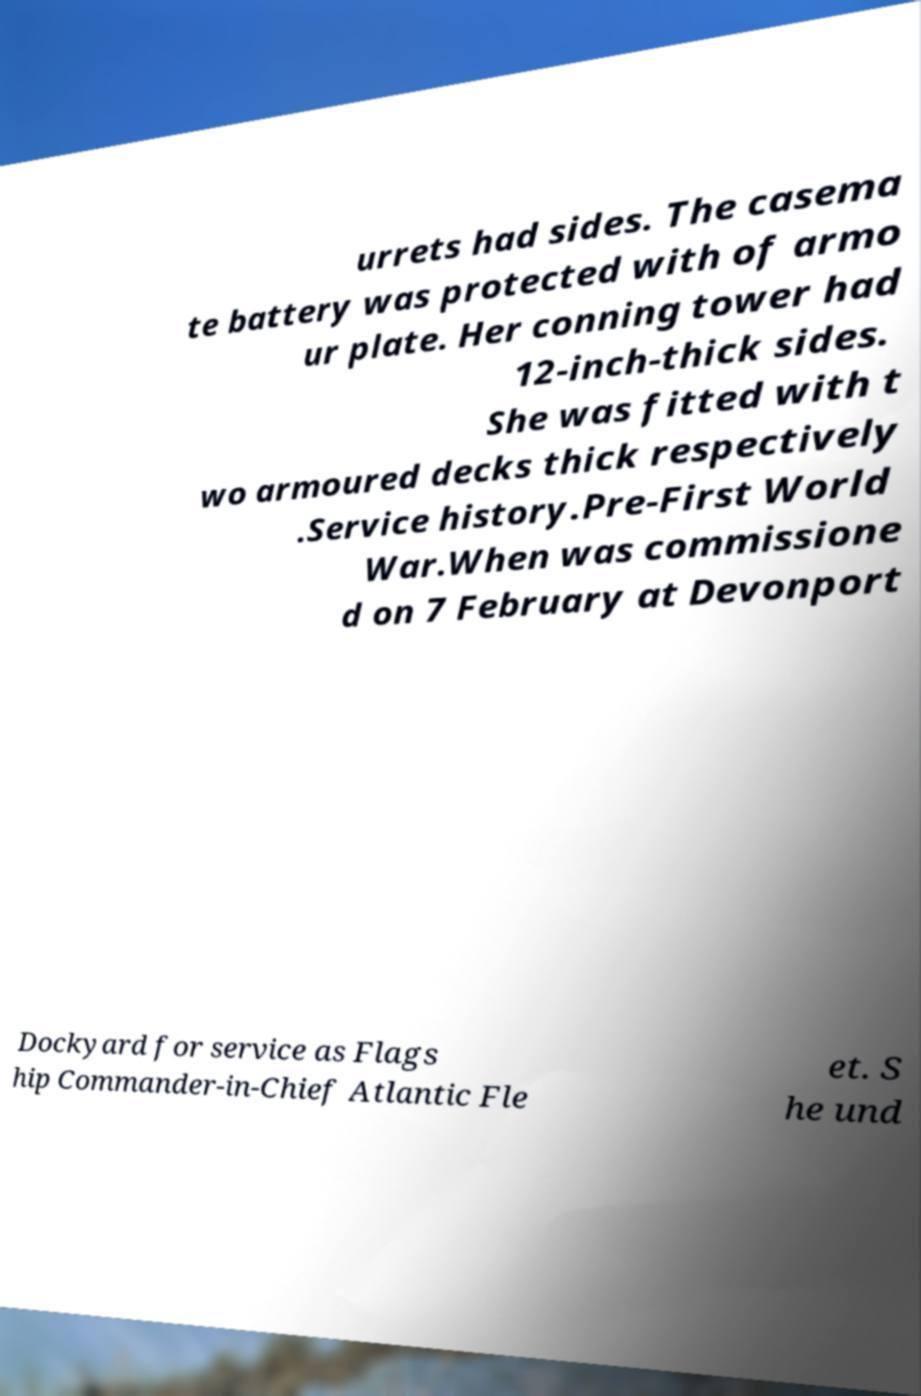Could you extract and type out the text from this image? urrets had sides. The casema te battery was protected with of armo ur plate. Her conning tower had 12-inch-thick sides. She was fitted with t wo armoured decks thick respectively .Service history.Pre-First World War.When was commissione d on 7 February at Devonport Dockyard for service as Flags hip Commander-in-Chief Atlantic Fle et. S he und 